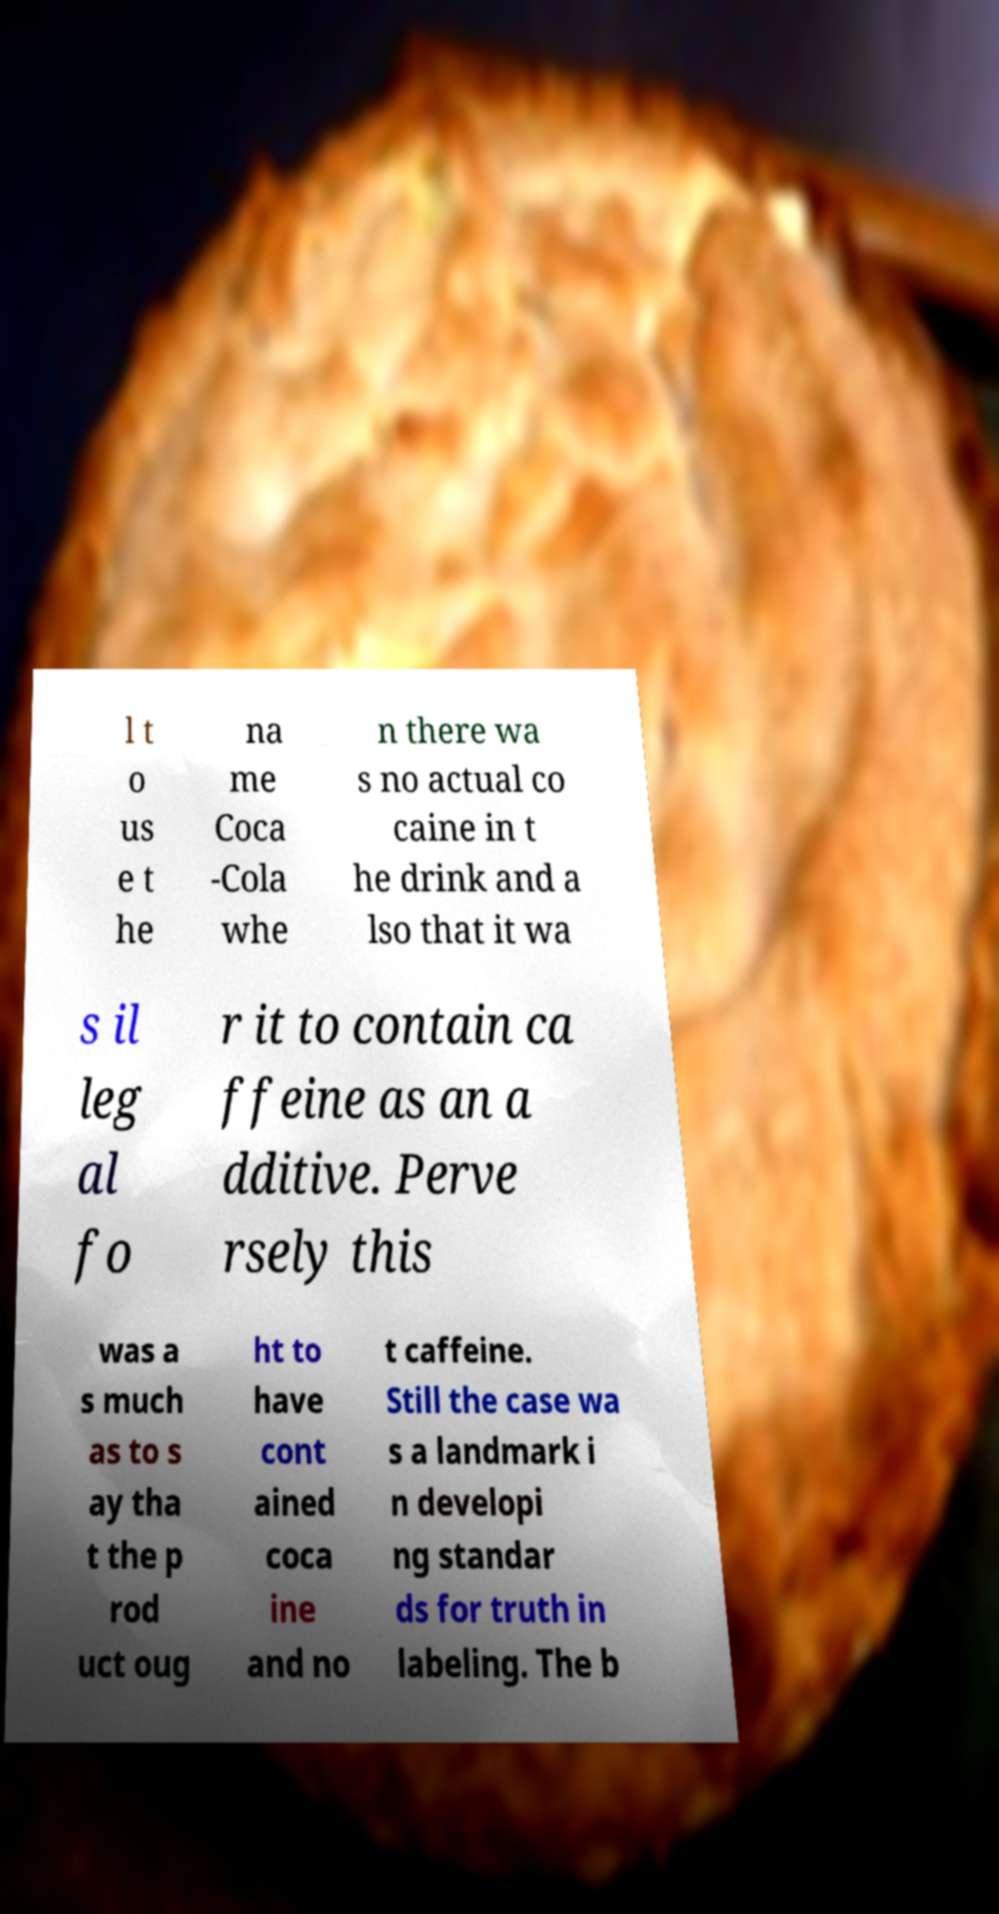I need the written content from this picture converted into text. Can you do that? l t o us e t he na me Coca -Cola whe n there wa s no actual co caine in t he drink and a lso that it wa s il leg al fo r it to contain ca ffeine as an a dditive. Perve rsely this was a s much as to s ay tha t the p rod uct oug ht to have cont ained coca ine and no t caffeine. Still the case wa s a landmark i n developi ng standar ds for truth in labeling. The b 